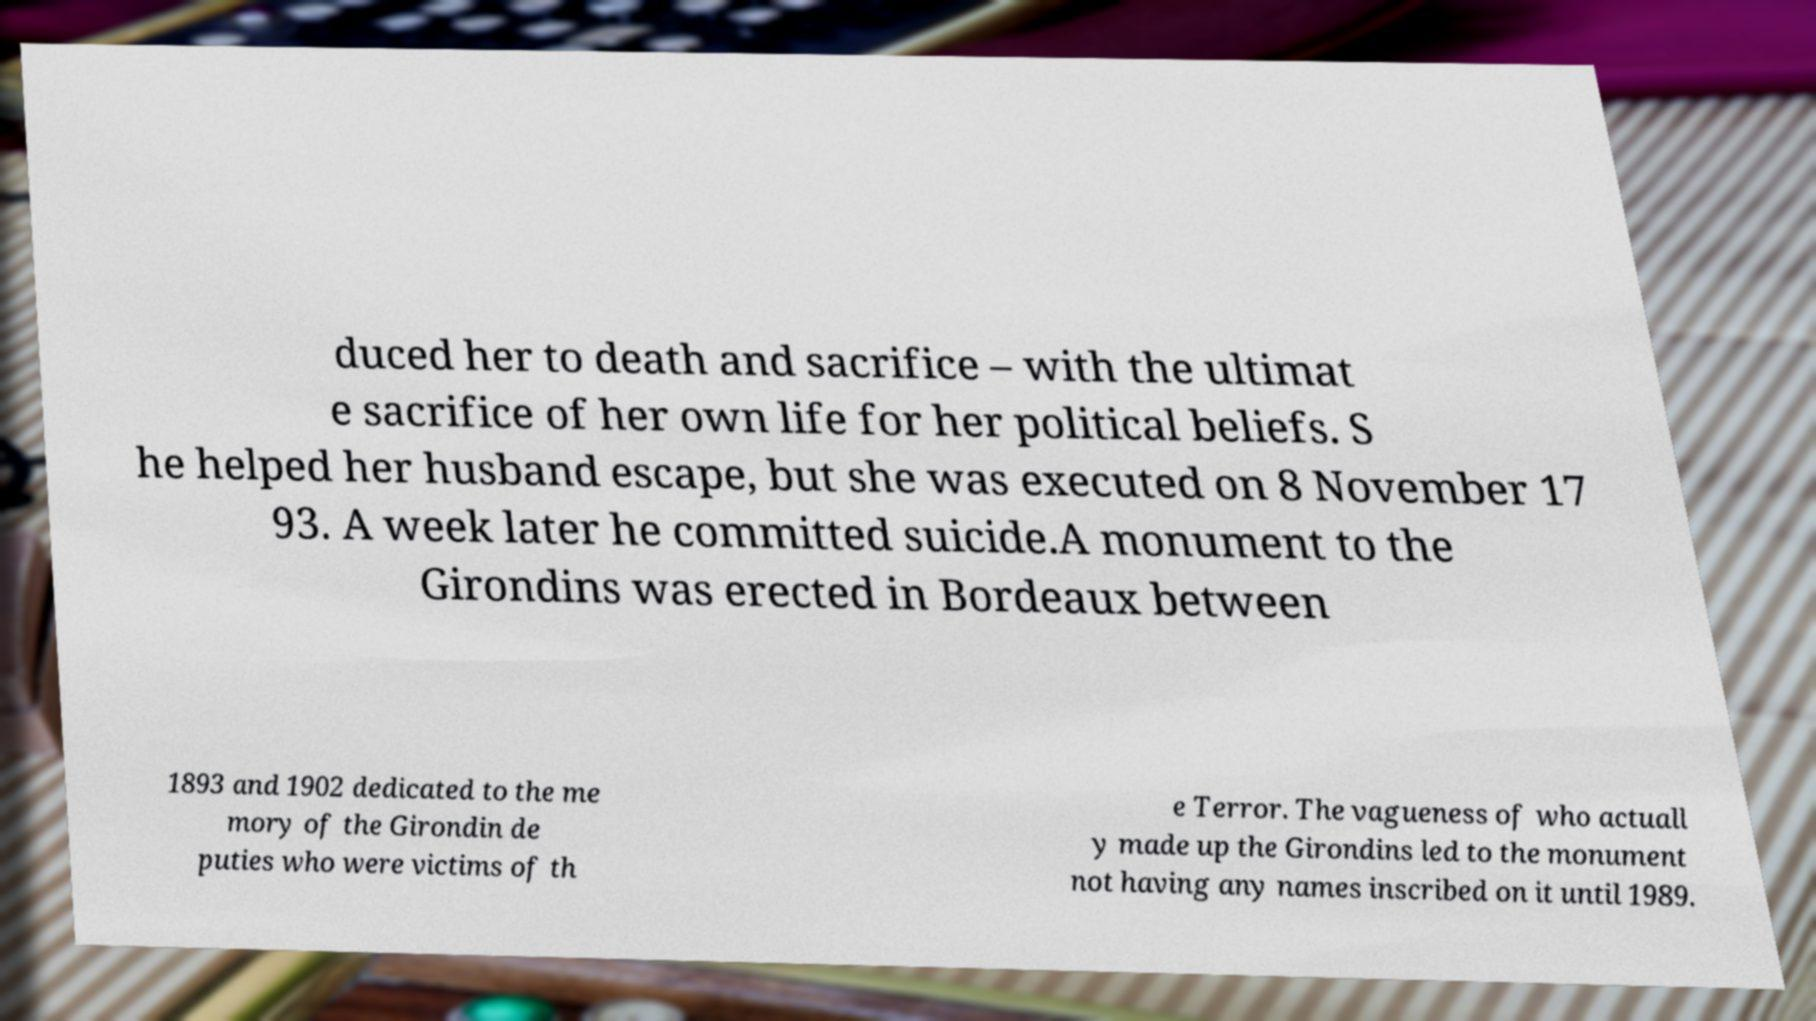There's text embedded in this image that I need extracted. Can you transcribe it verbatim? duced her to death and sacrifice – with the ultimat e sacrifice of her own life for her political beliefs. S he helped her husband escape, but she was executed on 8 November 17 93. A week later he committed suicide.A monument to the Girondins was erected in Bordeaux between 1893 and 1902 dedicated to the me mory of the Girondin de puties who were victims of th e Terror. The vagueness of who actuall y made up the Girondins led to the monument not having any names inscribed on it until 1989. 